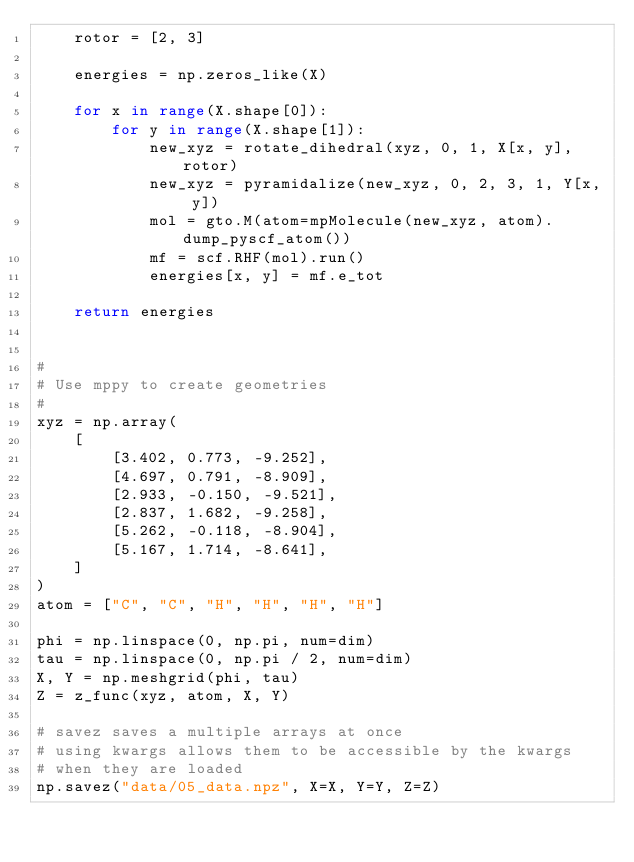<code> <loc_0><loc_0><loc_500><loc_500><_Python_>    rotor = [2, 3]

    energies = np.zeros_like(X)

    for x in range(X.shape[0]):
        for y in range(X.shape[1]):
            new_xyz = rotate_dihedral(xyz, 0, 1, X[x, y], rotor)
            new_xyz = pyramidalize(new_xyz, 0, 2, 3, 1, Y[x, y])
            mol = gto.M(atom=mpMolecule(new_xyz, atom).dump_pyscf_atom())
            mf = scf.RHF(mol).run()
            energies[x, y] = mf.e_tot

    return energies


#
# Use mppy to create geometries
#
xyz = np.array(
    [
        [3.402, 0.773, -9.252],
        [4.697, 0.791, -8.909],
        [2.933, -0.150, -9.521],
        [2.837, 1.682, -9.258],
        [5.262, -0.118, -8.904],
        [5.167, 1.714, -8.641],
    ]
)
atom = ["C", "C", "H", "H", "H", "H"]

phi = np.linspace(0, np.pi, num=dim)
tau = np.linspace(0, np.pi / 2, num=dim)
X, Y = np.meshgrid(phi, tau)
Z = z_func(xyz, atom, X, Y)

# savez saves a multiple arrays at once
# using kwargs allows them to be accessible by the kwargs
# when they are loaded
np.savez("data/05_data.npz", X=X, Y=Y, Z=Z)

</code> 